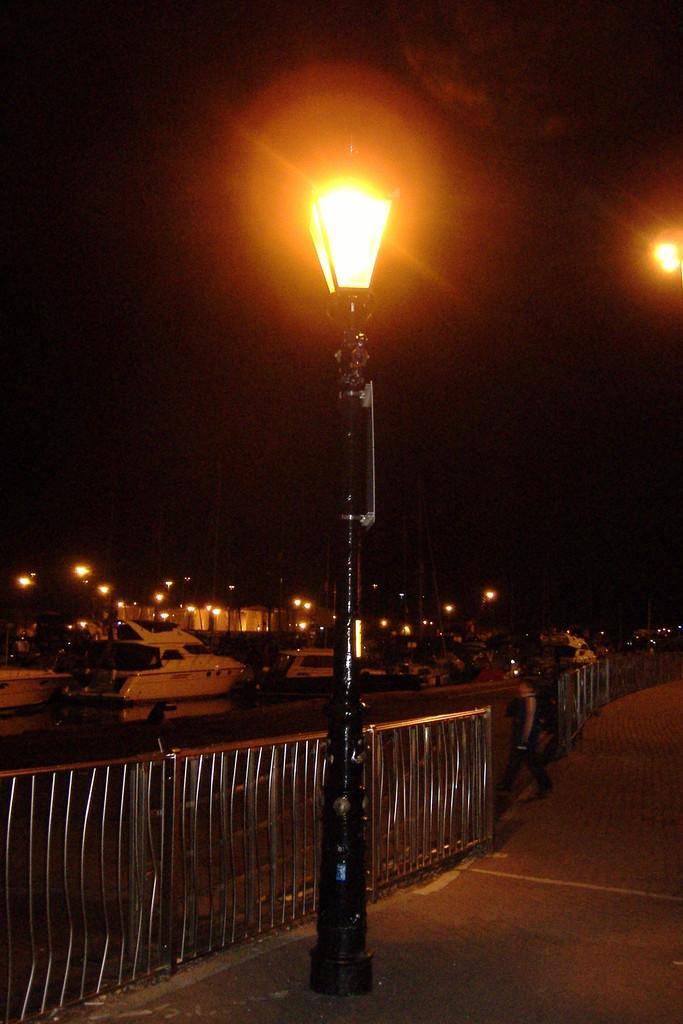Could you give a brief overview of what you see in this image? In this image I can see the ground, a black colored pole with a light on it, the railing, the water, few boats on the water, a person and few light poles. In the background I can see the dark sky. 